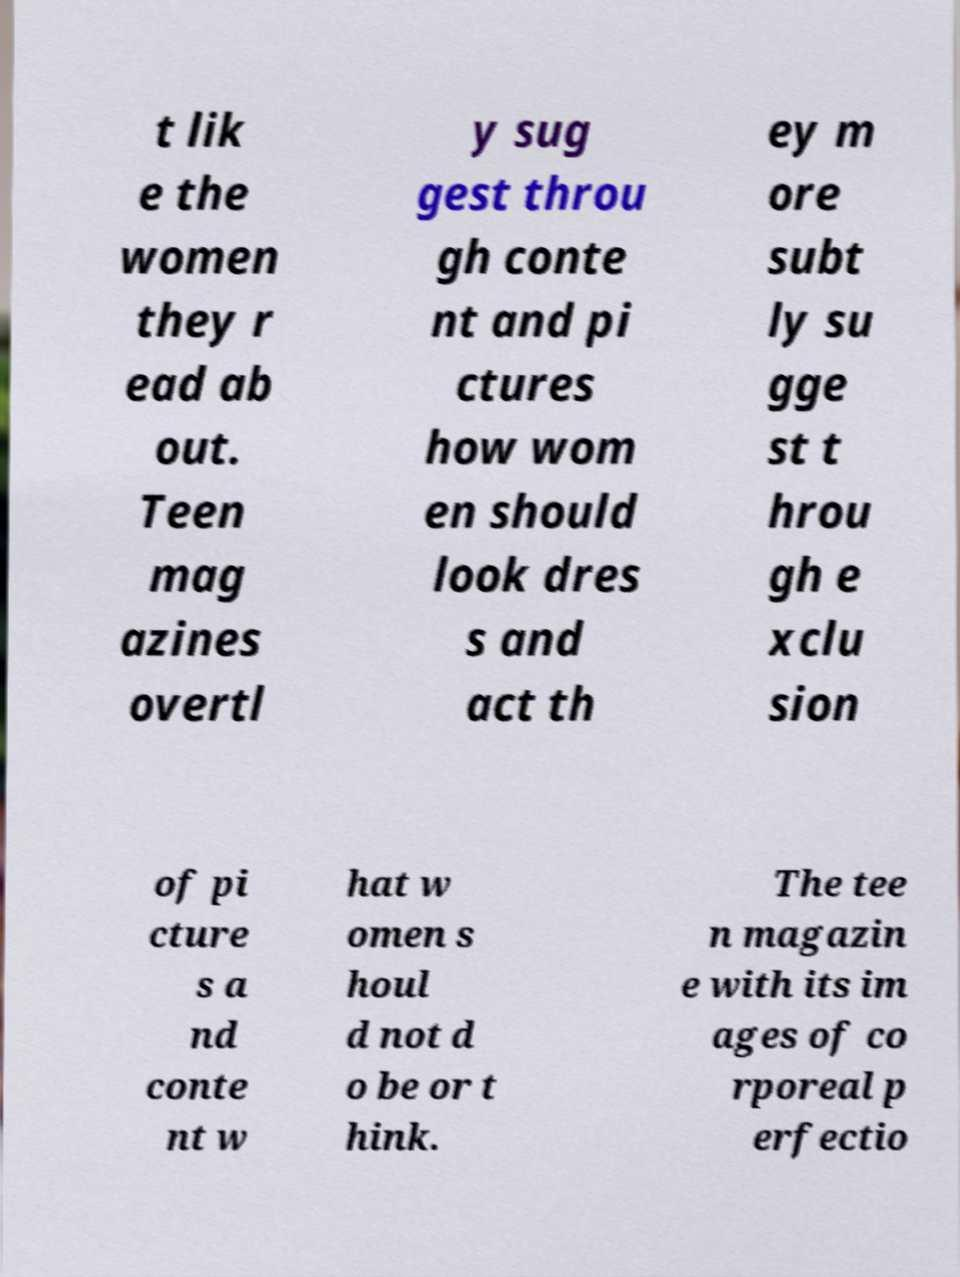For documentation purposes, I need the text within this image transcribed. Could you provide that? t lik e the women they r ead ab out. Teen mag azines overtl y sug gest throu gh conte nt and pi ctures how wom en should look dres s and act th ey m ore subt ly su gge st t hrou gh e xclu sion of pi cture s a nd conte nt w hat w omen s houl d not d o be or t hink. The tee n magazin e with its im ages of co rporeal p erfectio 